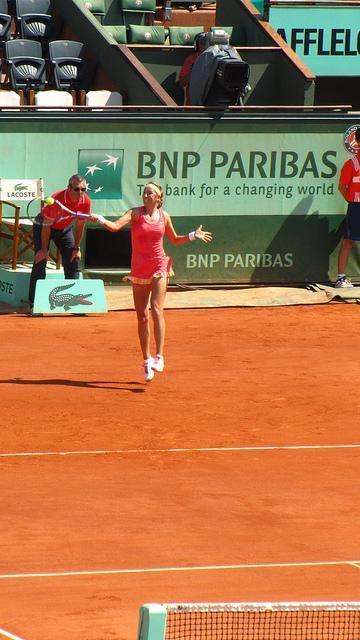How many chairs can be seen?
Give a very brief answer. 2. How many people are there?
Give a very brief answer. 2. 